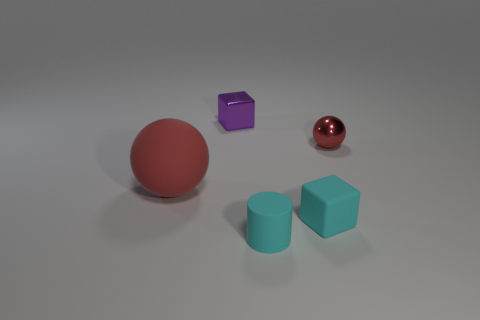How do the objects in the image vary in material and what does that suggest about their use? The objects showcase a variety of materials: the small sphere has a reflective, metallic surface; the large sphere has a matte finish; and the cubes have a solid, plastic-like appearance. This variety suggests they could be used for different purposes, with the metallic one perhaps being decorative, while the matte and plastic ones could be more utilitarian. 